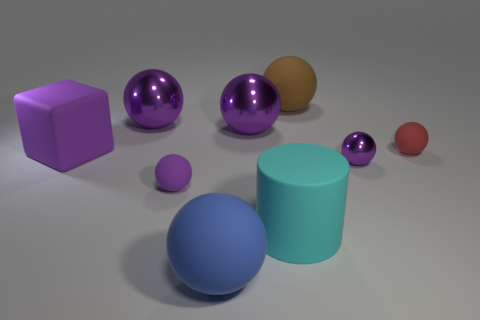How many purple balls must be subtracted to get 3 purple balls? 1 Subtract all brown cylinders. How many purple spheres are left? 4 Subtract all large matte balls. How many balls are left? 5 Subtract 1 balls. How many balls are left? 6 Subtract all red spheres. How many spheres are left? 6 Add 1 big metal things. How many objects exist? 10 Subtract all cyan balls. Subtract all brown blocks. How many balls are left? 7 Subtract all cubes. How many objects are left? 8 Subtract all purple matte spheres. Subtract all big cyan matte cylinders. How many objects are left? 7 Add 3 big purple cubes. How many big purple cubes are left? 4 